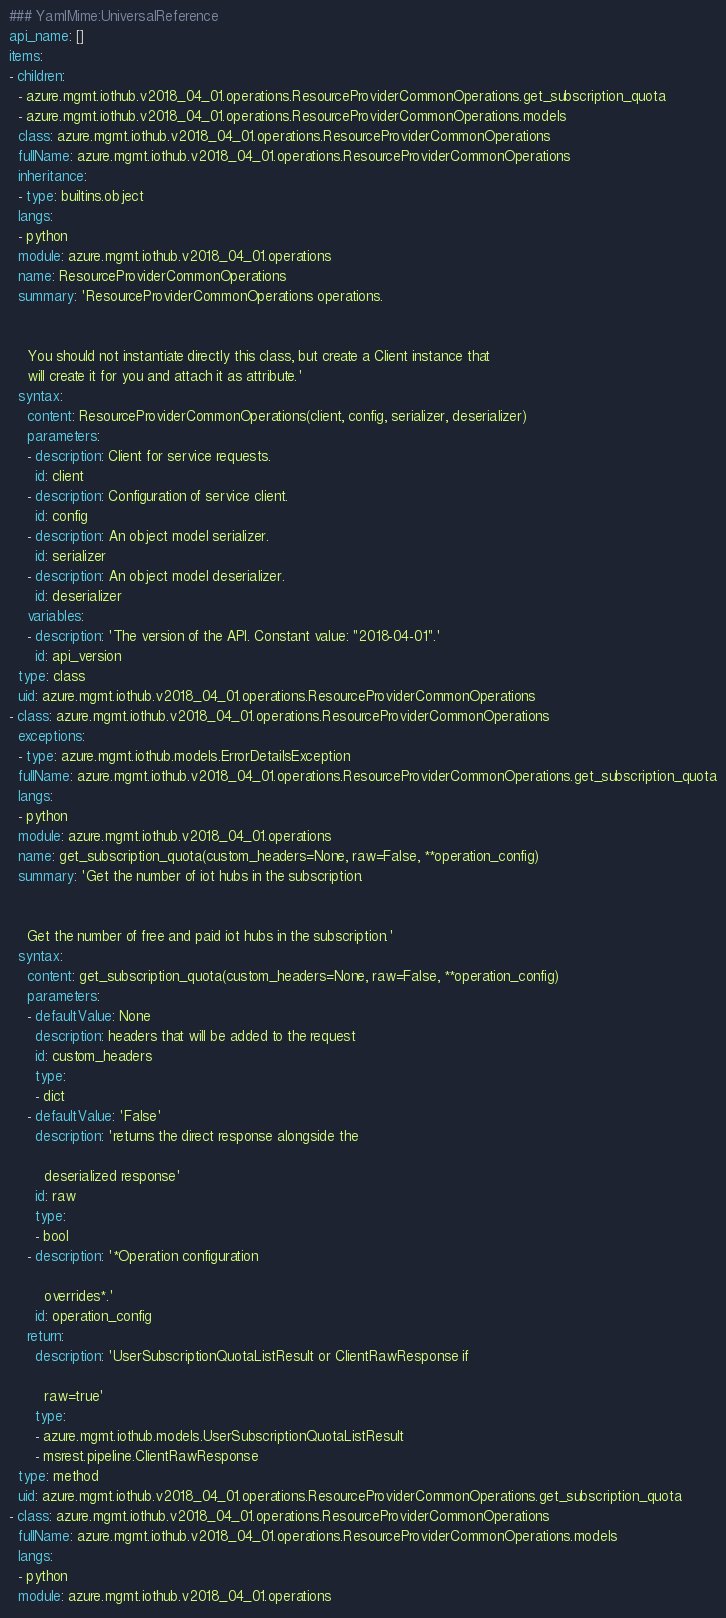Convert code to text. <code><loc_0><loc_0><loc_500><loc_500><_YAML_>### YamlMime:UniversalReference
api_name: []
items:
- children:
  - azure.mgmt.iothub.v2018_04_01.operations.ResourceProviderCommonOperations.get_subscription_quota
  - azure.mgmt.iothub.v2018_04_01.operations.ResourceProviderCommonOperations.models
  class: azure.mgmt.iothub.v2018_04_01.operations.ResourceProviderCommonOperations
  fullName: azure.mgmt.iothub.v2018_04_01.operations.ResourceProviderCommonOperations
  inheritance:
  - type: builtins.object
  langs:
  - python
  module: azure.mgmt.iothub.v2018_04_01.operations
  name: ResourceProviderCommonOperations
  summary: 'ResourceProviderCommonOperations operations.


    You should not instantiate directly this class, but create a Client instance that
    will create it for you and attach it as attribute.'
  syntax:
    content: ResourceProviderCommonOperations(client, config, serializer, deserializer)
    parameters:
    - description: Client for service requests.
      id: client
    - description: Configuration of service client.
      id: config
    - description: An object model serializer.
      id: serializer
    - description: An object model deserializer.
      id: deserializer
    variables:
    - description: 'The version of the API. Constant value: "2018-04-01".'
      id: api_version
  type: class
  uid: azure.mgmt.iothub.v2018_04_01.operations.ResourceProviderCommonOperations
- class: azure.mgmt.iothub.v2018_04_01.operations.ResourceProviderCommonOperations
  exceptions:
  - type: azure.mgmt.iothub.models.ErrorDetailsException
  fullName: azure.mgmt.iothub.v2018_04_01.operations.ResourceProviderCommonOperations.get_subscription_quota
  langs:
  - python
  module: azure.mgmt.iothub.v2018_04_01.operations
  name: get_subscription_quota(custom_headers=None, raw=False, **operation_config)
  summary: 'Get the number of iot hubs in the subscription.


    Get the number of free and paid iot hubs in the subscription.'
  syntax:
    content: get_subscription_quota(custom_headers=None, raw=False, **operation_config)
    parameters:
    - defaultValue: None
      description: headers that will be added to the request
      id: custom_headers
      type:
      - dict
    - defaultValue: 'False'
      description: 'returns the direct response alongside the

        deserialized response'
      id: raw
      type:
      - bool
    - description: '*Operation configuration

        overrides*.'
      id: operation_config
    return:
      description: 'UserSubscriptionQuotaListResult or ClientRawResponse if

        raw=true'
      type:
      - azure.mgmt.iothub.models.UserSubscriptionQuotaListResult
      - msrest.pipeline.ClientRawResponse
  type: method
  uid: azure.mgmt.iothub.v2018_04_01.operations.ResourceProviderCommonOperations.get_subscription_quota
- class: azure.mgmt.iothub.v2018_04_01.operations.ResourceProviderCommonOperations
  fullName: azure.mgmt.iothub.v2018_04_01.operations.ResourceProviderCommonOperations.models
  langs:
  - python
  module: azure.mgmt.iothub.v2018_04_01.operations</code> 